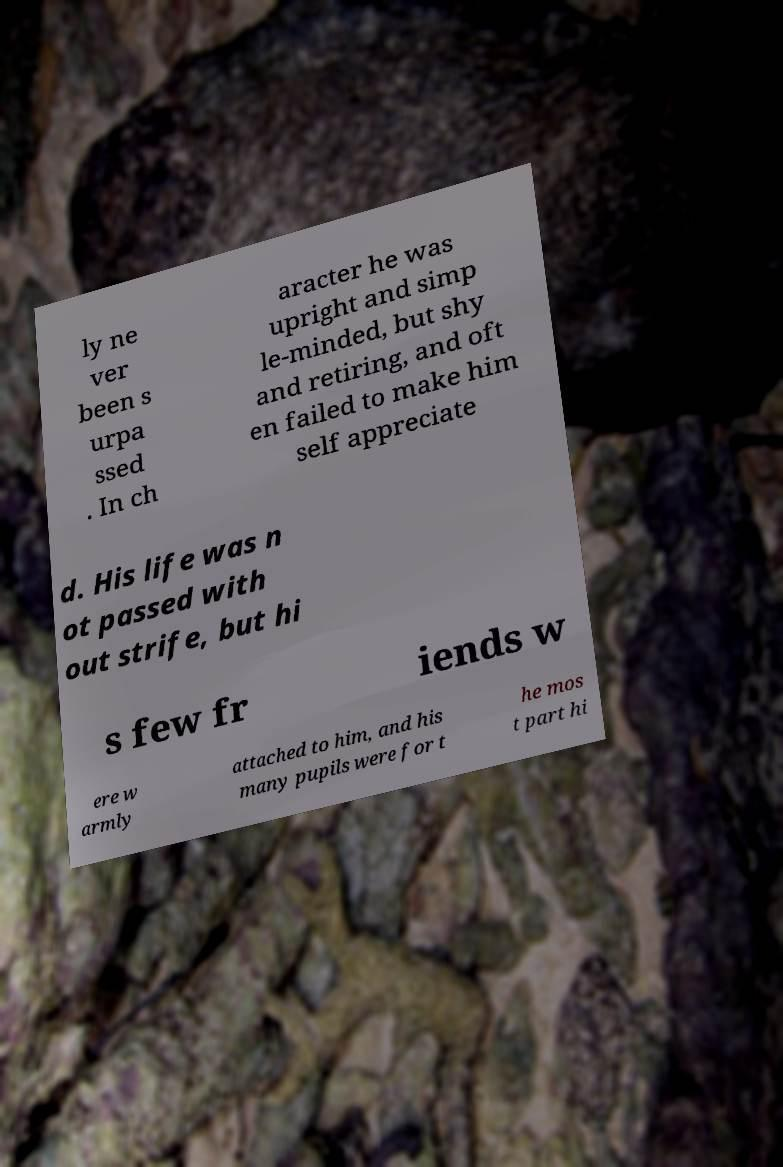Please read and relay the text visible in this image. What does it say? ly ne ver been s urpa ssed . In ch aracter he was upright and simp le-minded, but shy and retiring, and oft en failed to make him self appreciate d. His life was n ot passed with out strife, but hi s few fr iends w ere w armly attached to him, and his many pupils were for t he mos t part hi 